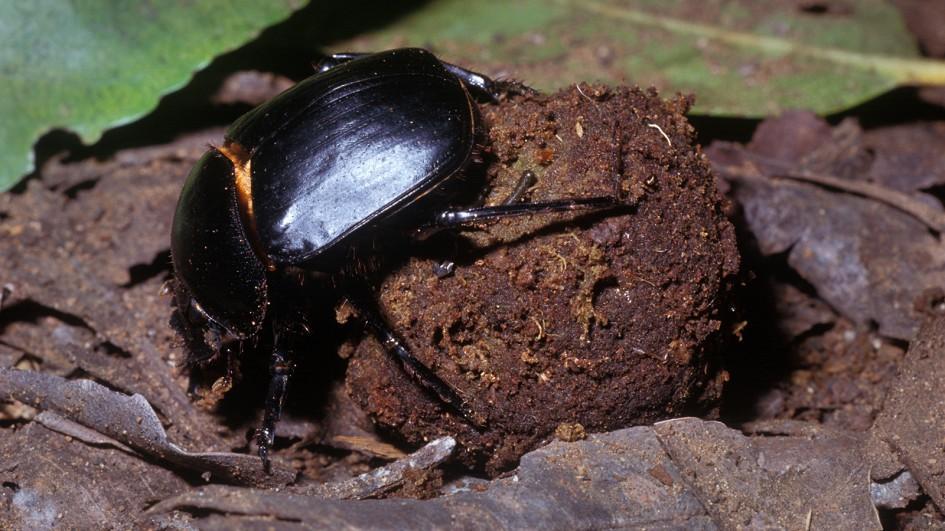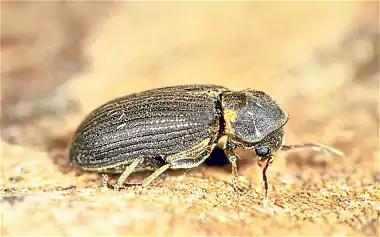The first image is the image on the left, the second image is the image on the right. For the images shown, is this caption "Both images show a beetle in contact with a round dung ball." true? Answer yes or no. No. The first image is the image on the left, the second image is the image on the right. Considering the images on both sides, is "At least one of the beetles is not on a clod of dirt." valid? Answer yes or no. Yes. 